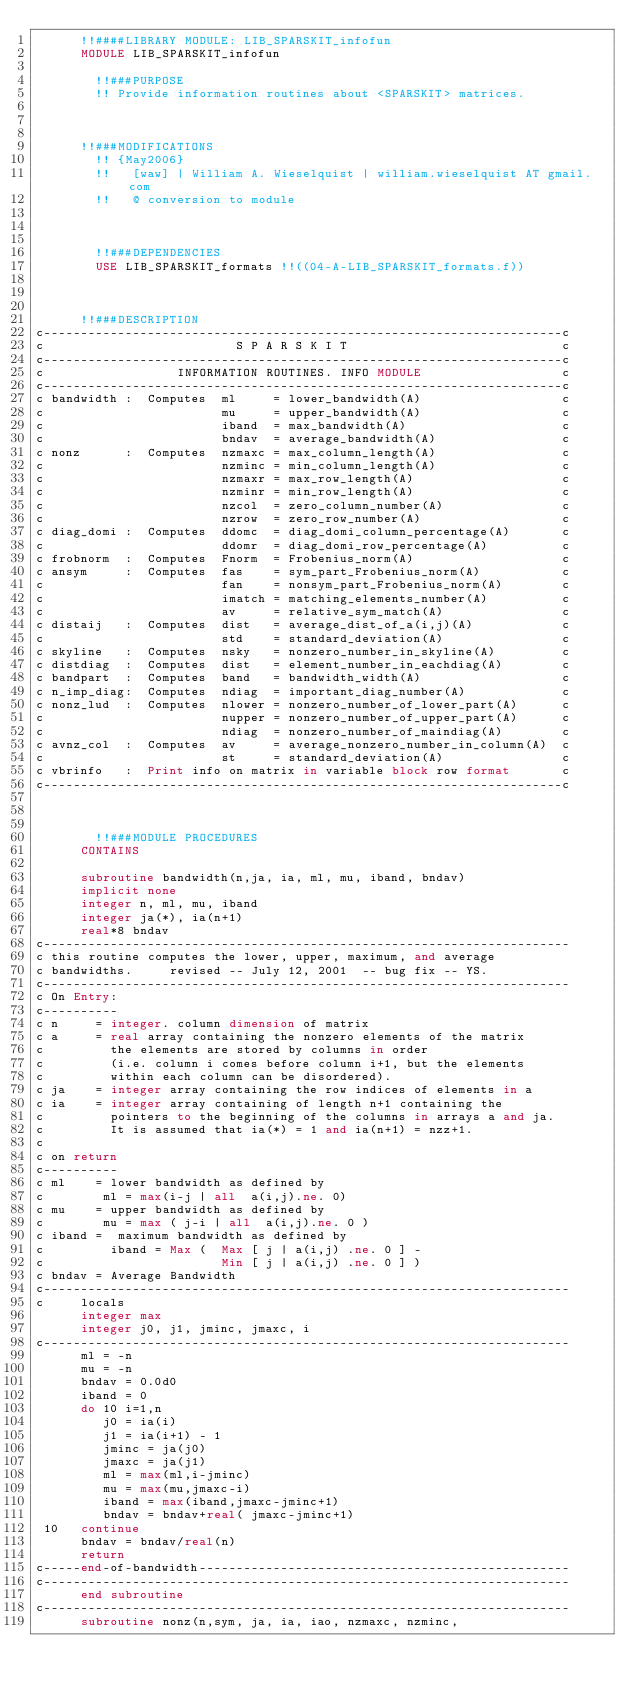Convert code to text. <code><loc_0><loc_0><loc_500><loc_500><_FORTRAN_>      !!####LIBRARY MODULE: LIB_SPARSKIT_infofun
      MODULE LIB_SPARSKIT_infofun

        !!###PURPOSE
        !! Provide information routines about <SPARSKIT> matrices.



      !!###MODIFICATIONS
        !! {May2006}
        !!   [waw] | William A. Wieselquist | william.wieselquist AT gmail.com
        !!   @ conversion to module



        !!###DEPENDENCIES
        USE LIB_SPARSKIT_formats !!((04-A-LIB_SPARSKIT_formats.f))



      !!###DESCRIPTION
c----------------------------------------------------------------------c
c                          S P A R S K I T                             c
c----------------------------------------------------------------------c
c                  INFORMATION ROUTINES. INFO MODULE                   c
c----------------------------------------------------------------------c
c bandwidth :  Computes  ml     = lower_bandwidth(A)                   c
c                        mu     = upper_bandwidth(A)                   c
c                        iband  = max_bandwidth(A)                     c
c                        bndav  = average_bandwidth(A)                 c
c nonz      :  Computes  nzmaxc = max_column_length(A)                 c
c                        nzminc = min_column_length(A)                 c
c                        nzmaxr = max_row_length(A)                    c
c                        nzminr = min_row_length(A)                    c
c                        nzcol  = zero_column_number(A)                c
c                        nzrow  = zero_row_number(A)                   c
c diag_domi :  Computes  ddomc  = diag_domi_column_percentage(A)       c
c                        ddomr  = diag_domi_row_percentage(A)          c
c frobnorm  :  Computes  Fnorm  = Frobenius_norm(A)                    c
c ansym     :  Computes  fas    = sym_part_Frobenius_norm(A)           c
c                        fan    = nonsym_part_Frobenius_norm(A)        c
c                        imatch = matching_elements_number(A)          c
c                        av     = relative_sym_match(A)                c
c distaij   :  Computes  dist   = average_dist_of_a(i,j)(A)            c
c                        std    = standard_deviation(A)                c
c skyline   :  Computes  nsky   = nonzero_number_in_skyline(A)         c
c distdiag  :  Computes  dist   = element_number_in_eachdiag(A)        c
c bandpart  :  Computes  band   = bandwidth_width(A)                   c
c n_imp_diag:  Computes  ndiag  = important_diag_number(A)             c
c nonz_lud  :  Computes  nlower = nonzero_number_of_lower_part(A)      c
c                        nupper = nonzero_number_of_upper_part(A)      c
c                        ndiag  = nonzero_number_of_maindiag(A)        c
c avnz_col  :  Computes  av     = average_nonzero_number_in_column(A)  c
c                        st     = standard_deviation(A)                c
c vbrinfo   :  Print info on matrix in variable block row format       c
c----------------------------------------------------------------------c



        !!###MODULE PROCEDURES
      CONTAINS

      subroutine bandwidth(n,ja, ia, ml, mu, iband, bndav)
      implicit none
      integer n, ml, mu, iband
      integer ja(*), ia(n+1)
      real*8 bndav
c-----------------------------------------------------------------------
c this routine computes the lower, upper, maximum, and average
c bandwidths.     revised -- July 12, 2001  -- bug fix -- YS.
c-----------------------------------------------------------------------
c On Entry:
c----------
c n     = integer. column dimension of matrix
c a     = real array containing the nonzero elements of the matrix
c         the elements are stored by columns in order
c         (i.e. column i comes before column i+1, but the elements
c         within each column can be disordered).
c ja    = integer array containing the row indices of elements in a
c ia    = integer array containing of length n+1 containing the
c         pointers to the beginning of the columns in arrays a and ja.
c         It is assumed that ia(*) = 1 and ia(n+1) = nzz+1.
c
c on return
c----------
c ml    = lower bandwidth as defined by
c        ml = max(i-j | all  a(i,j).ne. 0)
c mu    = upper bandwidth as defined by
c        mu = max ( j-i | all  a(i,j).ne. 0 )
c iband =  maximum bandwidth as defined by
c         iband = Max (  Max [ j | a(i,j) .ne. 0 ] -
c                        Min [ j | a(i,j) .ne. 0 ] )
c bndav = Average Bandwidth
c-----------------------------------------------------------------------
c     locals
      integer max
      integer j0, j1, jminc, jmaxc, i
c-----------------------------------------------------------------------
      ml = -n
      mu = -n
      bndav = 0.0d0
      iband = 0
      do 10 i=1,n
         j0 = ia(i)
         j1 = ia(i+1) - 1
         jminc = ja(j0)
         jmaxc = ja(j1)
         ml = max(ml,i-jminc)
         mu = max(mu,jmaxc-i)
         iband = max(iband,jmaxc-jminc+1)
         bndav = bndav+real( jmaxc-jminc+1)
 10   continue
      bndav = bndav/real(n)
      return
c-----end-of-bandwidth--------------------------------------------------
c-----------------------------------------------------------------------
      end subroutine
c-----------------------------------------------------------------------
      subroutine nonz(n,sym, ja, ia, iao, nzmaxc, nzminc,</code> 